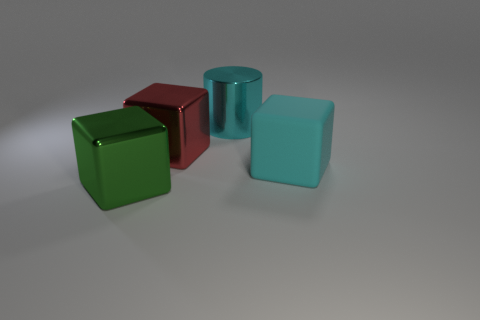Subtract all metal blocks. How many blocks are left? 1 Add 4 large cyan rubber balls. How many objects exist? 8 Subtract all blocks. How many objects are left? 1 Add 3 small green shiny balls. How many small green shiny balls exist? 3 Subtract 1 red cubes. How many objects are left? 3 Subtract all yellow balls. Subtract all big metal things. How many objects are left? 1 Add 3 rubber things. How many rubber things are left? 4 